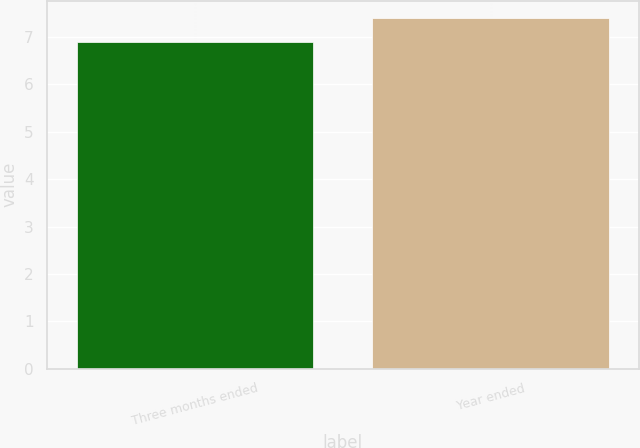Convert chart to OTSL. <chart><loc_0><loc_0><loc_500><loc_500><bar_chart><fcel>Three months ended<fcel>Year ended<nl><fcel>6.9<fcel>7.4<nl></chart> 